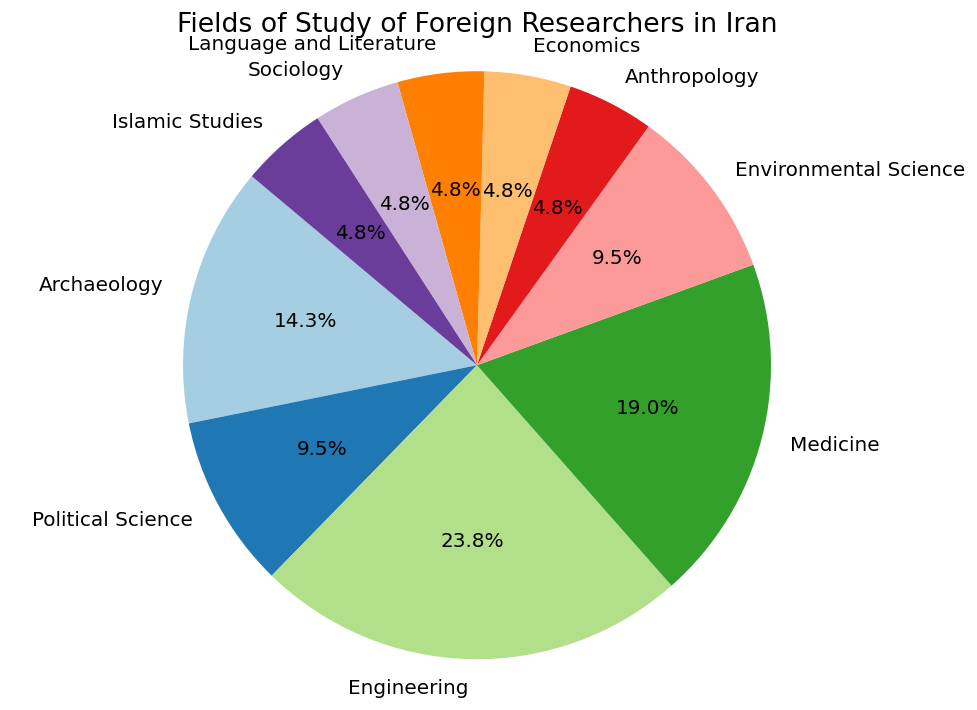What is the largest field of study represented by foreign researchers in Iran? The pie chart shows the percentage distribution of various fields of study. The largest segment is represented by Engineering, which is 25%.
Answer: Engineering How many fields of study are represented by 5% of the foreign researchers? To determine this, look at the chart and count the number of fields with a 5% label. Anthropology, Economics, Language and Literature, Sociology, and Islamic Studies are each represented by 5%.
Answer: 5 Is Environmental Science represented by a greater or lesser percentage compared to Political Science? By comparing the segments in the pie chart, Environmental Science is 10%, which is the same as Political Science.
Answer: Equal What is the combined percentage of foreign researchers in Iran studying Medicine and Archaeology? Add the percentages for Medicine (20%) and Archaeology (15%) from the chart. The combined total is 20% + 15% = 35%.
Answer: 35% Which field of study has a representation closest in percentage to Sociology? Sociology is represented by 5%. The fields with the closest percentages are Anthropology, Economics, Language and Literature, and Islamic Studies, all with 5%.
Answer: Anthropology, Economics, Language and Literature, Islamic Studies If you were to group Engineering and Medicine together, what percentage of foreign researchers would they make up? Add the percentages for Engineering (25%) and Medicine (20%). The combined percentage is 25% + 20% = 45%.
Answer: 45% Which fields of study combined have the same percentage representation as Engineering? Engineering is 25%. By observing the chart, several combinations could work, such as Archaeology (15%) + Political Science (10%) together.
Answer: Archaeology and Political Science What is the difference in percentage between the fields with the highest and lowest representation? The highest representation is Engineering (25%), and the lowest are Anthropology, Economics, Language and Literature, Sociology, and Islamic Studies (each 5%). Difference is 25% - 5% = 20%.
Answer: 20% What percentage of the foreign researchers are studying Environmental Science and Political Science combined? Add the percentages for Environmental Science (10%) and Political Science (10%). The combined percentage is 10% + 10% = 20%.
Answer: 20% What is the second-largest field of study represented by foreign researchers in Iran? After Engineering (25%), the next largest segment on the pie chart is Medicine (20%).
Answer: Medicine 